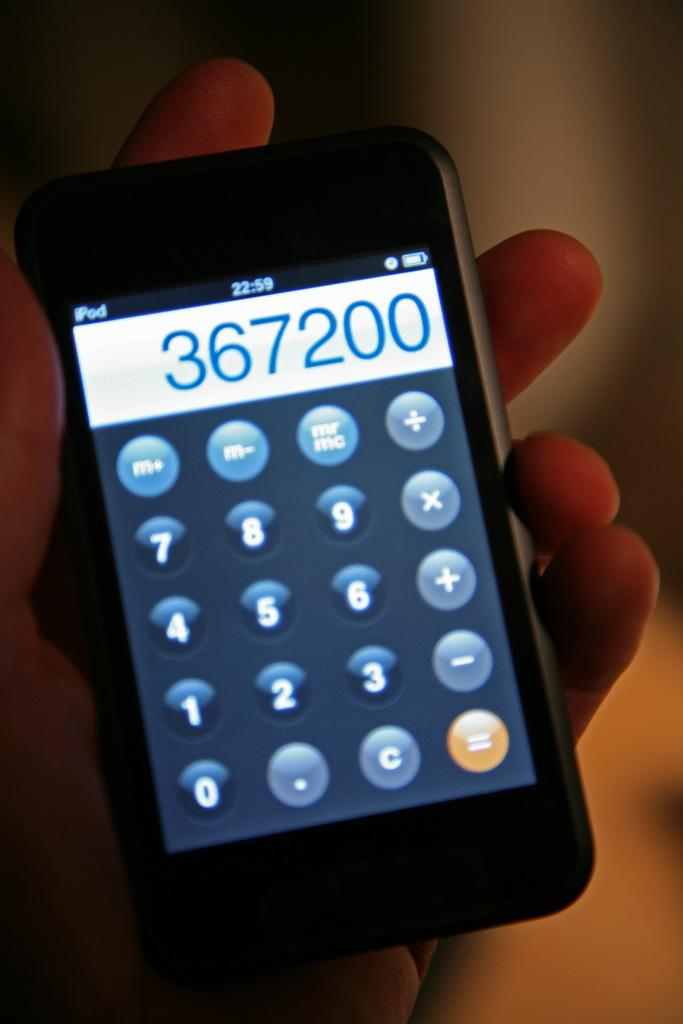Provide a one-sentence caption for the provided image. a phone is displayed with the numbers 367200 written in a calculator app. 